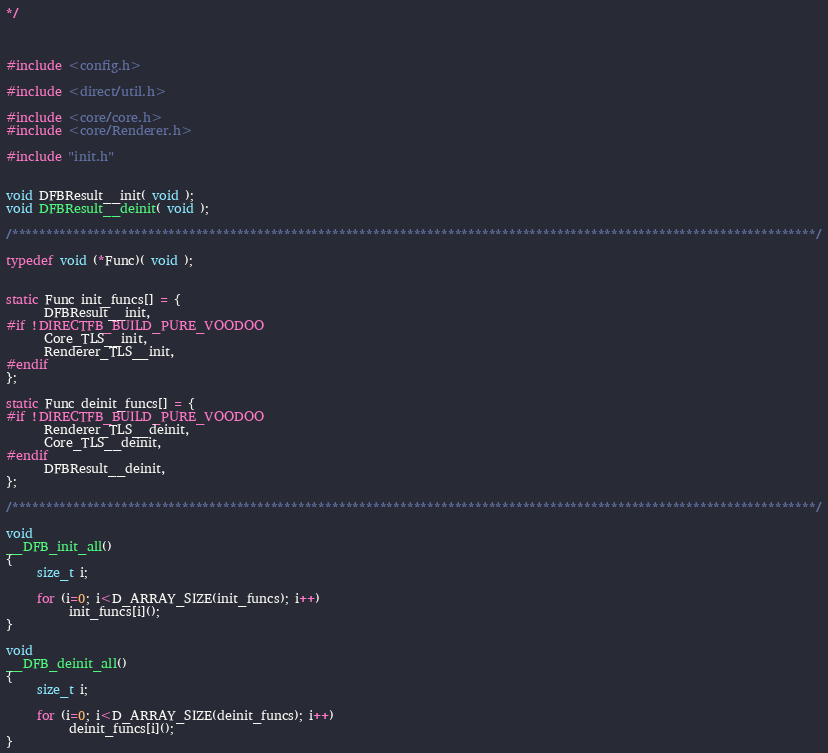<code> <loc_0><loc_0><loc_500><loc_500><_C_>*/



#include <config.h>

#include <direct/util.h>

#include <core/core.h>
#include <core/Renderer.h>

#include "init.h"


void DFBResult__init( void );
void DFBResult__deinit( void );

/**********************************************************************************************************************/

typedef void (*Func)( void );


static Func init_funcs[] = {
      DFBResult__init,
#if !DIRECTFB_BUILD_PURE_VOODOO
      Core_TLS__init,
      Renderer_TLS__init,
#endif
};

static Func deinit_funcs[] = {
#if !DIRECTFB_BUILD_PURE_VOODOO
      Renderer_TLS__deinit,
      Core_TLS__deinit,
#endif
      DFBResult__deinit,
};

/**********************************************************************************************************************/

void
__DFB_init_all()
{
     size_t i;

     for (i=0; i<D_ARRAY_SIZE(init_funcs); i++)
          init_funcs[i]();
}

void
__DFB_deinit_all()
{
     size_t i;

     for (i=0; i<D_ARRAY_SIZE(deinit_funcs); i++)
          deinit_funcs[i]();
}

</code> 